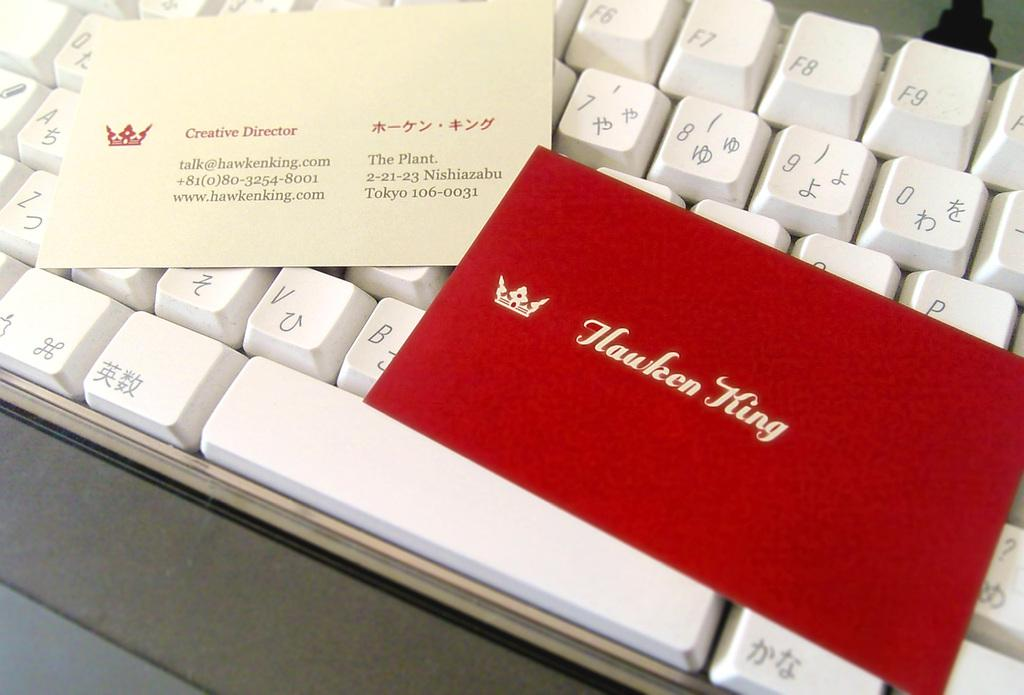<image>
Offer a succinct explanation of the picture presented. Red business card for Hawken King on top of a keyboard. 